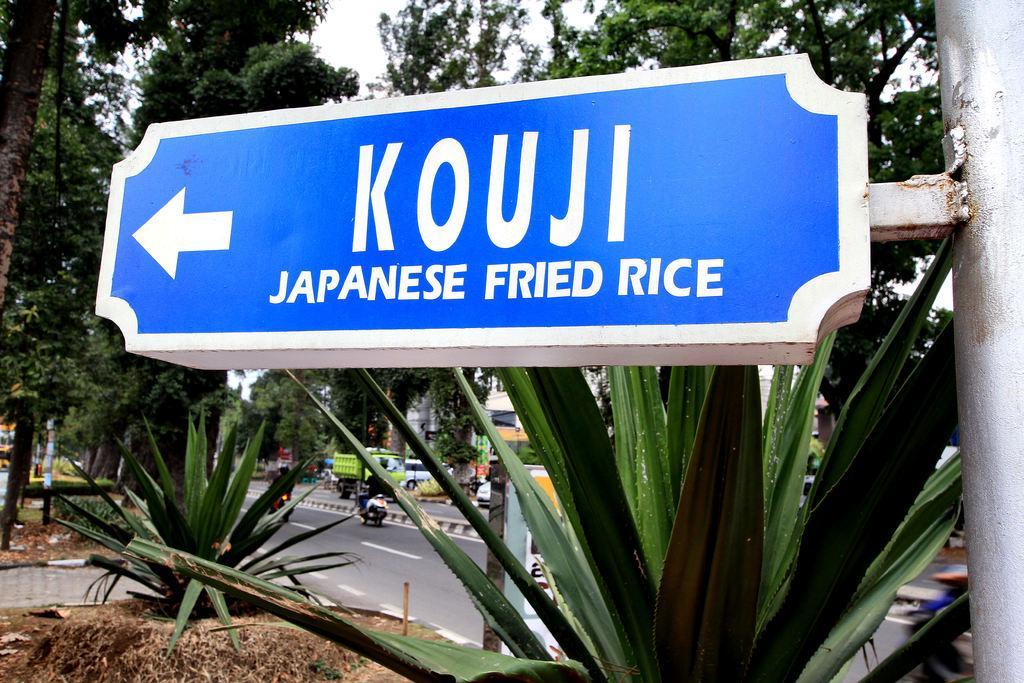Describe this image in one or two sentences. On the right side of the image there is a pole, on the pole there is a sign board. Behind the pole there are some trees and poles and plants and buildings. Behind the trees there are some vehicles on the road. 